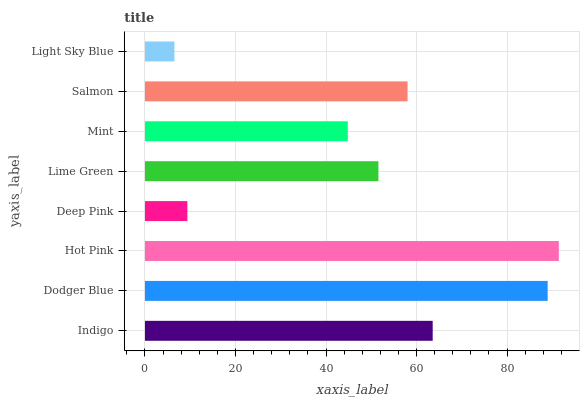Is Light Sky Blue the minimum?
Answer yes or no. Yes. Is Hot Pink the maximum?
Answer yes or no. Yes. Is Dodger Blue the minimum?
Answer yes or no. No. Is Dodger Blue the maximum?
Answer yes or no. No. Is Dodger Blue greater than Indigo?
Answer yes or no. Yes. Is Indigo less than Dodger Blue?
Answer yes or no. Yes. Is Indigo greater than Dodger Blue?
Answer yes or no. No. Is Dodger Blue less than Indigo?
Answer yes or no. No. Is Salmon the high median?
Answer yes or no. Yes. Is Lime Green the low median?
Answer yes or no. Yes. Is Mint the high median?
Answer yes or no. No. Is Dodger Blue the low median?
Answer yes or no. No. 